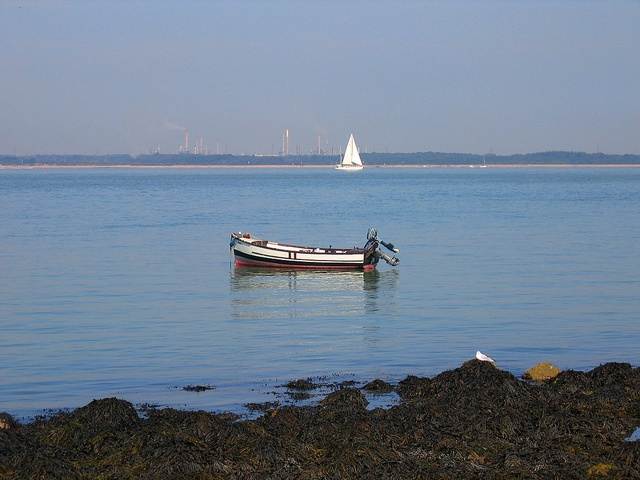Describe the objects in this image and their specific colors. I can see boat in darkgray, black, ivory, and gray tones, boat in darkgray, ivory, and lightgray tones, bird in darkgray, white, and gray tones, and boat in darkgray, gray, beige, and pink tones in this image. 